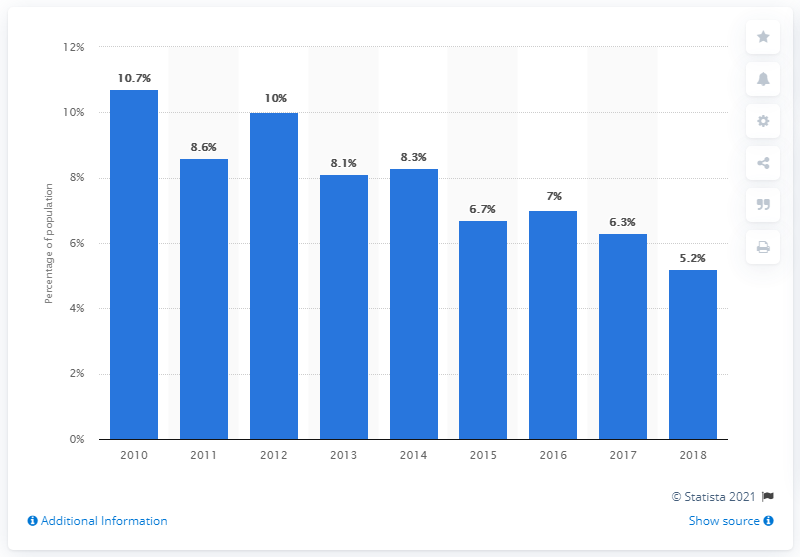Give some essential details in this illustration. In 2018, approximately 25.8% of the Panamanian population lived on less than $3.20 per day, according to data from the World Bank. In 2010, approximately 10.7% of the Panamanian population lived on less than 3.20 dollars per day, according to data. 